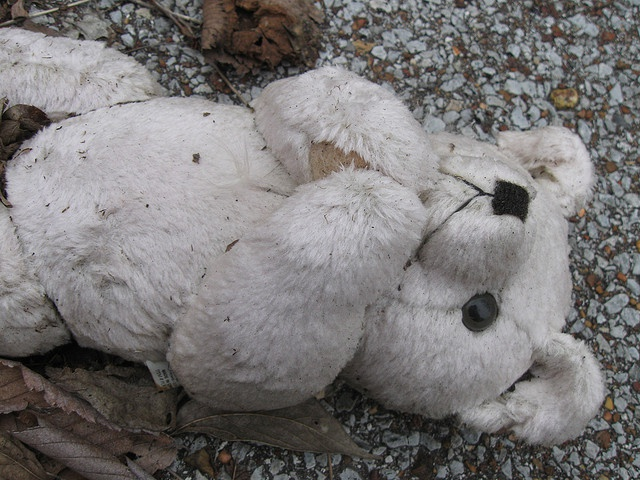Describe the objects in this image and their specific colors. I can see a teddy bear in black, darkgray, gray, and lightgray tones in this image. 